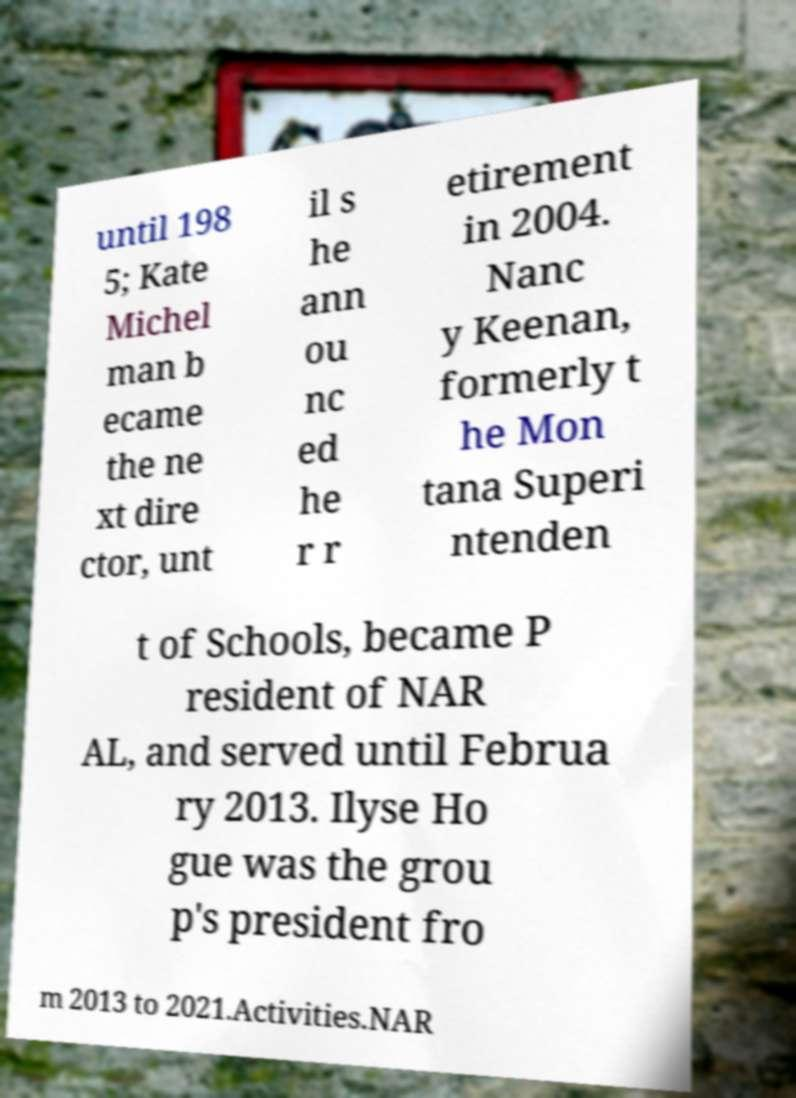Can you read and provide the text displayed in the image?This photo seems to have some interesting text. Can you extract and type it out for me? until 198 5; Kate Michel man b ecame the ne xt dire ctor, unt il s he ann ou nc ed he r r etirement in 2004. Nanc y Keenan, formerly t he Mon tana Superi ntenden t of Schools, became P resident of NAR AL, and served until Februa ry 2013. Ilyse Ho gue was the grou p's president fro m 2013 to 2021.Activities.NAR 